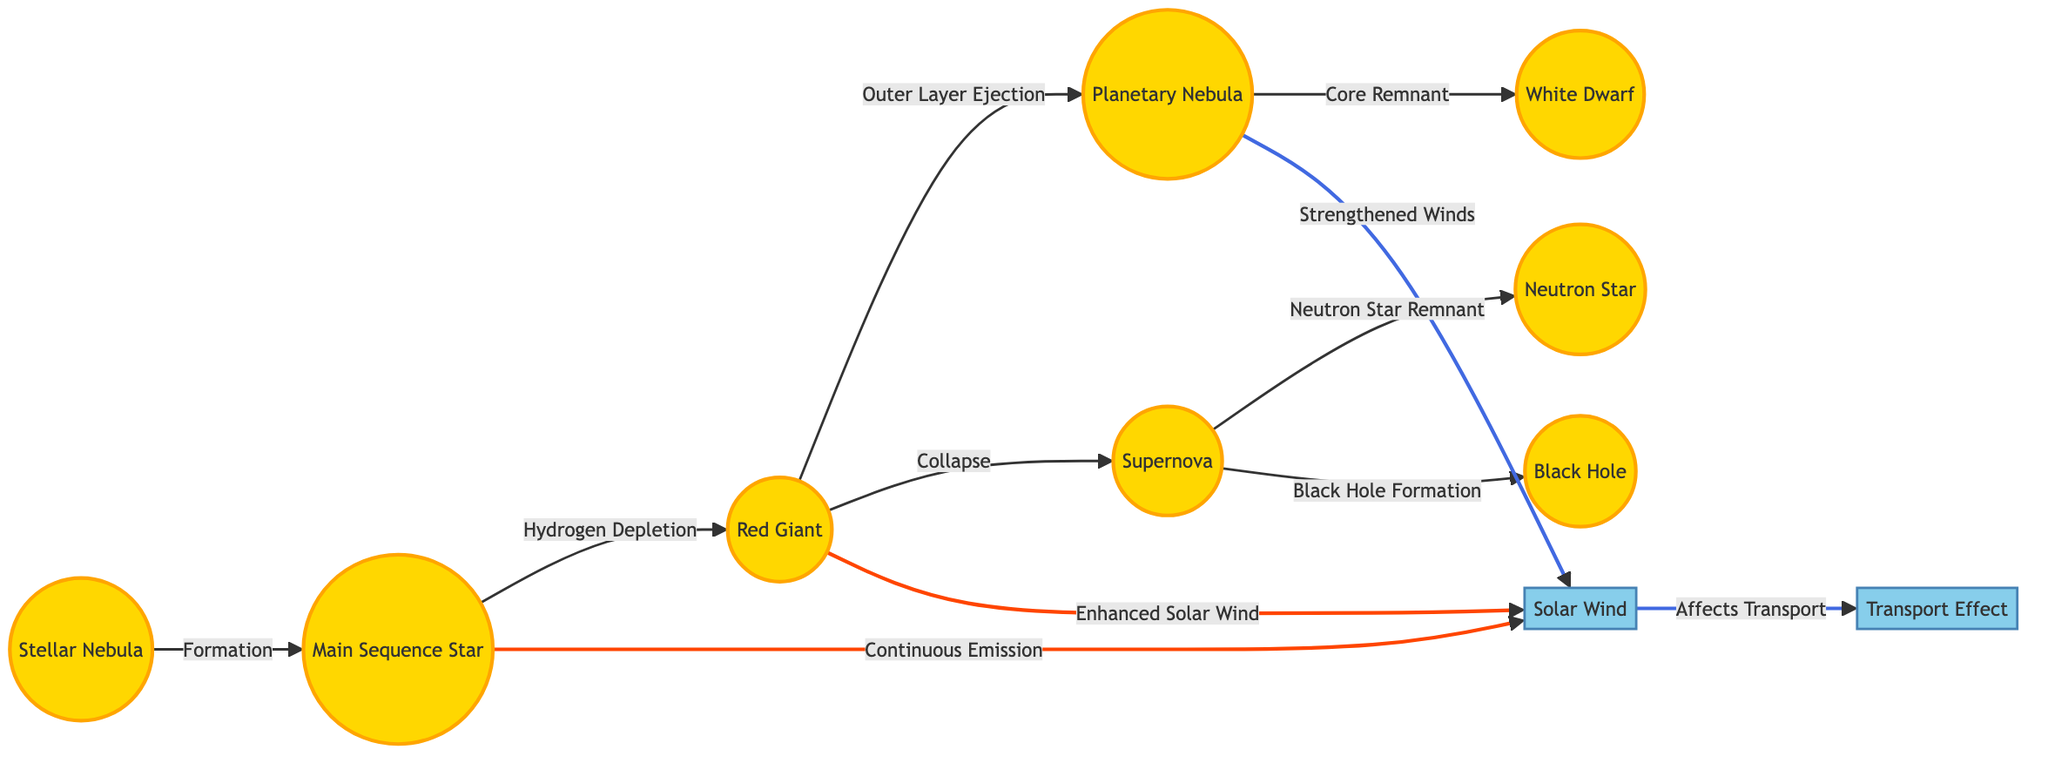What is the first stage of stellar evolution listed in the diagram? The diagram shows that the first stage of stellar evolution is the "Stellar Nebula," which is represented as node 1.
Answer: Stellar Nebula How many total stages of stellar evolution are shown in the diagram? By counting the nodes in the diagram, we find that there are a total of eight stages: Stellar Nebula, Main Sequence Star, Red Giant, Planetary Nebula, White Dwarf, Supernova, Neutron Star, and Black Hole.
Answer: 8 What process occurs after a Main Sequence Star? The flow from the Main Sequence Star (node 2) leads to hydrogen depletion, resulting in the next stage, which is the "Red Giant" (node 3).
Answer: Red Giant Which stage directly leads to a White Dwarf? The diagram indicates that the process leading to a White Dwarf (node 5) follows the formation of a "Planetary Nebula" (node 4), indicating a direct connection.
Answer: Planetary Nebula What effect does the Red Giant have on solar wind? The diagram shows that the Red Giant stage (node 3) leads to "Enhanced Solar Wind," depicting a specific effect tied to its evolution stage.
Answer: Enhanced Solar Wind What is the final evolutionary stage that can be formed from a supernova? According to the diagram, a supernova can lead to two outcomes: a "Neutron Star" (node 7) or a "Black Hole" (node 8), indicating multiple final states.
Answer: Neutron Star or Black Hole Which stage is followed by core remnant formation? From the diagram, after the "Planetary Nebula" (node 4) stage, the process leads to the formation of a core remnant, which defines the next stage as a "White Dwarf" (node 5).
Answer: White Dwarf What does Solar Wind influence according to the diagram? The diagram reveals that Solar Wind (node 9) has a direct line leading to "Transport Effect" (node 10), indicating its impact on transportation.
Answer: Transport Effect 